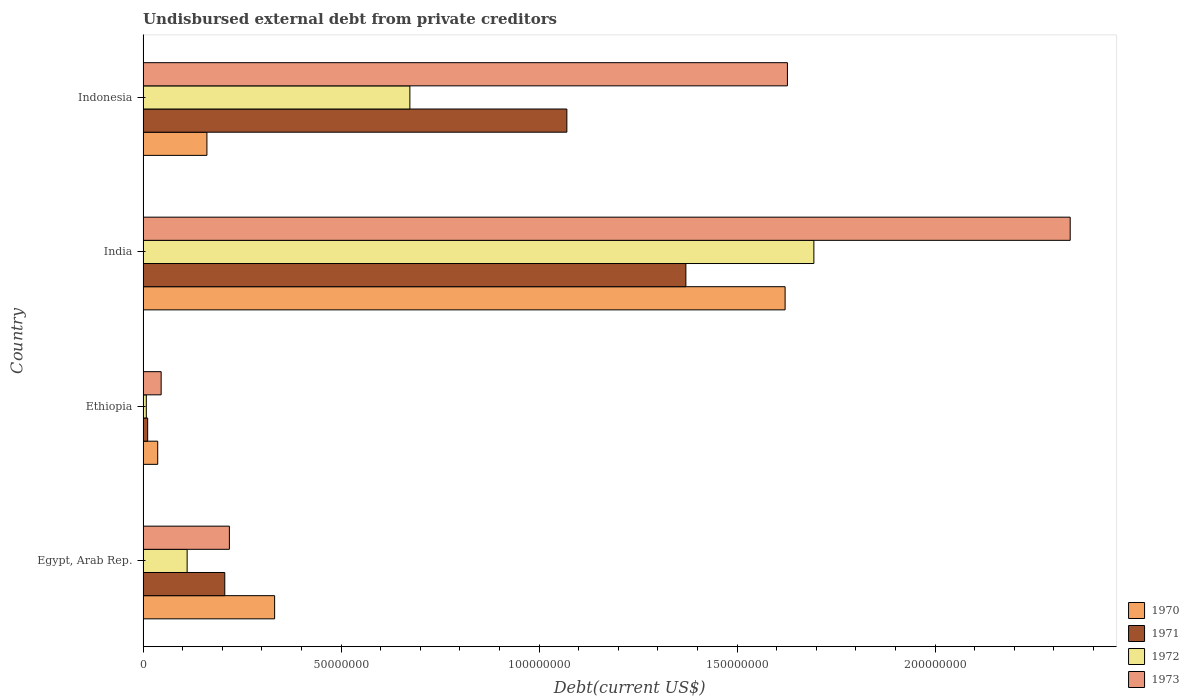How many groups of bars are there?
Keep it short and to the point. 4. Are the number of bars per tick equal to the number of legend labels?
Offer a very short reply. Yes. How many bars are there on the 1st tick from the bottom?
Your answer should be compact. 4. What is the label of the 2nd group of bars from the top?
Your response must be concise. India. What is the total debt in 1971 in Egypt, Arab Rep.?
Provide a short and direct response. 2.06e+07. Across all countries, what is the maximum total debt in 1970?
Give a very brief answer. 1.62e+08. Across all countries, what is the minimum total debt in 1973?
Your response must be concise. 4.57e+06. In which country was the total debt in 1972 minimum?
Make the answer very short. Ethiopia. What is the total total debt in 1973 in the graph?
Provide a short and direct response. 4.23e+08. What is the difference between the total debt in 1970 in Ethiopia and that in India?
Your response must be concise. -1.58e+08. What is the difference between the total debt in 1972 in Indonesia and the total debt in 1973 in Ethiopia?
Your answer should be very brief. 6.28e+07. What is the average total debt in 1971 per country?
Offer a very short reply. 6.65e+07. What is the difference between the total debt in 1971 and total debt in 1972 in Indonesia?
Offer a very short reply. 3.96e+07. What is the ratio of the total debt in 1972 in Ethiopia to that in India?
Ensure brevity in your answer.  0. Is the total debt in 1970 in Ethiopia less than that in Indonesia?
Offer a terse response. Yes. Is the difference between the total debt in 1971 in Ethiopia and India greater than the difference between the total debt in 1972 in Ethiopia and India?
Keep it short and to the point. Yes. What is the difference between the highest and the second highest total debt in 1970?
Provide a short and direct response. 1.29e+08. What is the difference between the highest and the lowest total debt in 1973?
Your answer should be very brief. 2.30e+08. Is the sum of the total debt in 1973 in Egypt, Arab Rep. and India greater than the maximum total debt in 1970 across all countries?
Make the answer very short. Yes. Is it the case that in every country, the sum of the total debt in 1970 and total debt in 1971 is greater than the sum of total debt in 1973 and total debt in 1972?
Offer a terse response. No. What does the 4th bar from the top in Indonesia represents?
Provide a short and direct response. 1970. Are all the bars in the graph horizontal?
Keep it short and to the point. Yes. How many countries are there in the graph?
Ensure brevity in your answer.  4. Where does the legend appear in the graph?
Your answer should be very brief. Bottom right. How many legend labels are there?
Offer a very short reply. 4. What is the title of the graph?
Your answer should be very brief. Undisbursed external debt from private creditors. What is the label or title of the X-axis?
Ensure brevity in your answer.  Debt(current US$). What is the label or title of the Y-axis?
Your response must be concise. Country. What is the Debt(current US$) in 1970 in Egypt, Arab Rep.?
Provide a succinct answer. 3.32e+07. What is the Debt(current US$) of 1971 in Egypt, Arab Rep.?
Give a very brief answer. 2.06e+07. What is the Debt(current US$) in 1972 in Egypt, Arab Rep.?
Give a very brief answer. 1.11e+07. What is the Debt(current US$) in 1973 in Egypt, Arab Rep.?
Provide a succinct answer. 2.18e+07. What is the Debt(current US$) of 1970 in Ethiopia?
Provide a short and direct response. 3.70e+06. What is the Debt(current US$) in 1971 in Ethiopia?
Make the answer very short. 1.16e+06. What is the Debt(current US$) in 1972 in Ethiopia?
Offer a terse response. 8.20e+05. What is the Debt(current US$) of 1973 in Ethiopia?
Offer a very short reply. 4.57e+06. What is the Debt(current US$) in 1970 in India?
Make the answer very short. 1.62e+08. What is the Debt(current US$) of 1971 in India?
Keep it short and to the point. 1.37e+08. What is the Debt(current US$) in 1972 in India?
Your answer should be compact. 1.69e+08. What is the Debt(current US$) of 1973 in India?
Provide a short and direct response. 2.34e+08. What is the Debt(current US$) in 1970 in Indonesia?
Provide a short and direct response. 1.61e+07. What is the Debt(current US$) of 1971 in Indonesia?
Give a very brief answer. 1.07e+08. What is the Debt(current US$) of 1972 in Indonesia?
Offer a terse response. 6.74e+07. What is the Debt(current US$) in 1973 in Indonesia?
Provide a short and direct response. 1.63e+08. Across all countries, what is the maximum Debt(current US$) of 1970?
Your answer should be very brief. 1.62e+08. Across all countries, what is the maximum Debt(current US$) in 1971?
Make the answer very short. 1.37e+08. Across all countries, what is the maximum Debt(current US$) of 1972?
Your answer should be very brief. 1.69e+08. Across all countries, what is the maximum Debt(current US$) in 1973?
Offer a very short reply. 2.34e+08. Across all countries, what is the minimum Debt(current US$) of 1970?
Make the answer very short. 3.70e+06. Across all countries, what is the minimum Debt(current US$) in 1971?
Keep it short and to the point. 1.16e+06. Across all countries, what is the minimum Debt(current US$) of 1972?
Provide a short and direct response. 8.20e+05. Across all countries, what is the minimum Debt(current US$) of 1973?
Keep it short and to the point. 4.57e+06. What is the total Debt(current US$) in 1970 in the graph?
Your answer should be compact. 2.15e+08. What is the total Debt(current US$) in 1971 in the graph?
Give a very brief answer. 2.66e+08. What is the total Debt(current US$) of 1972 in the graph?
Your response must be concise. 2.49e+08. What is the total Debt(current US$) of 1973 in the graph?
Provide a succinct answer. 4.23e+08. What is the difference between the Debt(current US$) in 1970 in Egypt, Arab Rep. and that in Ethiopia?
Keep it short and to the point. 2.95e+07. What is the difference between the Debt(current US$) of 1971 in Egypt, Arab Rep. and that in Ethiopia?
Make the answer very short. 1.95e+07. What is the difference between the Debt(current US$) in 1972 in Egypt, Arab Rep. and that in Ethiopia?
Your response must be concise. 1.03e+07. What is the difference between the Debt(current US$) in 1973 in Egypt, Arab Rep. and that in Ethiopia?
Provide a short and direct response. 1.72e+07. What is the difference between the Debt(current US$) in 1970 in Egypt, Arab Rep. and that in India?
Provide a succinct answer. -1.29e+08. What is the difference between the Debt(current US$) of 1971 in Egypt, Arab Rep. and that in India?
Your answer should be very brief. -1.16e+08. What is the difference between the Debt(current US$) of 1972 in Egypt, Arab Rep. and that in India?
Provide a succinct answer. -1.58e+08. What is the difference between the Debt(current US$) of 1973 in Egypt, Arab Rep. and that in India?
Offer a very short reply. -2.12e+08. What is the difference between the Debt(current US$) of 1970 in Egypt, Arab Rep. and that in Indonesia?
Provide a succinct answer. 1.71e+07. What is the difference between the Debt(current US$) in 1971 in Egypt, Arab Rep. and that in Indonesia?
Provide a succinct answer. -8.64e+07. What is the difference between the Debt(current US$) of 1972 in Egypt, Arab Rep. and that in Indonesia?
Your response must be concise. -5.62e+07. What is the difference between the Debt(current US$) of 1973 in Egypt, Arab Rep. and that in Indonesia?
Provide a succinct answer. -1.41e+08. What is the difference between the Debt(current US$) of 1970 in Ethiopia and that in India?
Provide a succinct answer. -1.58e+08. What is the difference between the Debt(current US$) in 1971 in Ethiopia and that in India?
Your answer should be compact. -1.36e+08. What is the difference between the Debt(current US$) in 1972 in Ethiopia and that in India?
Offer a terse response. -1.69e+08. What is the difference between the Debt(current US$) in 1973 in Ethiopia and that in India?
Offer a very short reply. -2.30e+08. What is the difference between the Debt(current US$) in 1970 in Ethiopia and that in Indonesia?
Keep it short and to the point. -1.24e+07. What is the difference between the Debt(current US$) of 1971 in Ethiopia and that in Indonesia?
Provide a short and direct response. -1.06e+08. What is the difference between the Debt(current US$) in 1972 in Ethiopia and that in Indonesia?
Keep it short and to the point. -6.66e+07. What is the difference between the Debt(current US$) in 1973 in Ethiopia and that in Indonesia?
Make the answer very short. -1.58e+08. What is the difference between the Debt(current US$) in 1970 in India and that in Indonesia?
Ensure brevity in your answer.  1.46e+08. What is the difference between the Debt(current US$) in 1971 in India and that in Indonesia?
Give a very brief answer. 3.00e+07. What is the difference between the Debt(current US$) in 1972 in India and that in Indonesia?
Offer a terse response. 1.02e+08. What is the difference between the Debt(current US$) in 1973 in India and that in Indonesia?
Your answer should be very brief. 7.14e+07. What is the difference between the Debt(current US$) of 1970 in Egypt, Arab Rep. and the Debt(current US$) of 1971 in Ethiopia?
Keep it short and to the point. 3.21e+07. What is the difference between the Debt(current US$) in 1970 in Egypt, Arab Rep. and the Debt(current US$) in 1972 in Ethiopia?
Provide a short and direct response. 3.24e+07. What is the difference between the Debt(current US$) in 1970 in Egypt, Arab Rep. and the Debt(current US$) in 1973 in Ethiopia?
Your response must be concise. 2.87e+07. What is the difference between the Debt(current US$) in 1971 in Egypt, Arab Rep. and the Debt(current US$) in 1972 in Ethiopia?
Give a very brief answer. 1.98e+07. What is the difference between the Debt(current US$) of 1971 in Egypt, Arab Rep. and the Debt(current US$) of 1973 in Ethiopia?
Your response must be concise. 1.61e+07. What is the difference between the Debt(current US$) of 1972 in Egypt, Arab Rep. and the Debt(current US$) of 1973 in Ethiopia?
Your answer should be very brief. 6.56e+06. What is the difference between the Debt(current US$) of 1970 in Egypt, Arab Rep. and the Debt(current US$) of 1971 in India?
Offer a terse response. -1.04e+08. What is the difference between the Debt(current US$) in 1970 in Egypt, Arab Rep. and the Debt(current US$) in 1972 in India?
Provide a short and direct response. -1.36e+08. What is the difference between the Debt(current US$) in 1970 in Egypt, Arab Rep. and the Debt(current US$) in 1973 in India?
Your answer should be very brief. -2.01e+08. What is the difference between the Debt(current US$) in 1971 in Egypt, Arab Rep. and the Debt(current US$) in 1972 in India?
Provide a short and direct response. -1.49e+08. What is the difference between the Debt(current US$) in 1971 in Egypt, Arab Rep. and the Debt(current US$) in 1973 in India?
Offer a very short reply. -2.13e+08. What is the difference between the Debt(current US$) of 1972 in Egypt, Arab Rep. and the Debt(current US$) of 1973 in India?
Offer a very short reply. -2.23e+08. What is the difference between the Debt(current US$) of 1970 in Egypt, Arab Rep. and the Debt(current US$) of 1971 in Indonesia?
Your response must be concise. -7.38e+07. What is the difference between the Debt(current US$) in 1970 in Egypt, Arab Rep. and the Debt(current US$) in 1972 in Indonesia?
Offer a very short reply. -3.42e+07. What is the difference between the Debt(current US$) of 1970 in Egypt, Arab Rep. and the Debt(current US$) of 1973 in Indonesia?
Your answer should be compact. -1.29e+08. What is the difference between the Debt(current US$) of 1971 in Egypt, Arab Rep. and the Debt(current US$) of 1972 in Indonesia?
Give a very brief answer. -4.67e+07. What is the difference between the Debt(current US$) of 1971 in Egypt, Arab Rep. and the Debt(current US$) of 1973 in Indonesia?
Provide a succinct answer. -1.42e+08. What is the difference between the Debt(current US$) of 1972 in Egypt, Arab Rep. and the Debt(current US$) of 1973 in Indonesia?
Offer a very short reply. -1.52e+08. What is the difference between the Debt(current US$) in 1970 in Ethiopia and the Debt(current US$) in 1971 in India?
Offer a terse response. -1.33e+08. What is the difference between the Debt(current US$) in 1970 in Ethiopia and the Debt(current US$) in 1972 in India?
Your answer should be compact. -1.66e+08. What is the difference between the Debt(current US$) in 1970 in Ethiopia and the Debt(current US$) in 1973 in India?
Provide a short and direct response. -2.30e+08. What is the difference between the Debt(current US$) in 1971 in Ethiopia and the Debt(current US$) in 1972 in India?
Your response must be concise. -1.68e+08. What is the difference between the Debt(current US$) in 1971 in Ethiopia and the Debt(current US$) in 1973 in India?
Keep it short and to the point. -2.33e+08. What is the difference between the Debt(current US$) in 1972 in Ethiopia and the Debt(current US$) in 1973 in India?
Ensure brevity in your answer.  -2.33e+08. What is the difference between the Debt(current US$) of 1970 in Ethiopia and the Debt(current US$) of 1971 in Indonesia?
Provide a short and direct response. -1.03e+08. What is the difference between the Debt(current US$) in 1970 in Ethiopia and the Debt(current US$) in 1972 in Indonesia?
Provide a short and direct response. -6.37e+07. What is the difference between the Debt(current US$) in 1970 in Ethiopia and the Debt(current US$) in 1973 in Indonesia?
Offer a very short reply. -1.59e+08. What is the difference between the Debt(current US$) of 1971 in Ethiopia and the Debt(current US$) of 1972 in Indonesia?
Ensure brevity in your answer.  -6.62e+07. What is the difference between the Debt(current US$) in 1971 in Ethiopia and the Debt(current US$) in 1973 in Indonesia?
Provide a short and direct response. -1.62e+08. What is the difference between the Debt(current US$) of 1972 in Ethiopia and the Debt(current US$) of 1973 in Indonesia?
Offer a terse response. -1.62e+08. What is the difference between the Debt(current US$) of 1970 in India and the Debt(current US$) of 1971 in Indonesia?
Ensure brevity in your answer.  5.51e+07. What is the difference between the Debt(current US$) in 1970 in India and the Debt(current US$) in 1972 in Indonesia?
Make the answer very short. 9.47e+07. What is the difference between the Debt(current US$) of 1970 in India and the Debt(current US$) of 1973 in Indonesia?
Offer a very short reply. -5.84e+05. What is the difference between the Debt(current US$) of 1971 in India and the Debt(current US$) of 1972 in Indonesia?
Make the answer very short. 6.97e+07. What is the difference between the Debt(current US$) of 1971 in India and the Debt(current US$) of 1973 in Indonesia?
Offer a terse response. -2.56e+07. What is the difference between the Debt(current US$) of 1972 in India and the Debt(current US$) of 1973 in Indonesia?
Provide a short and direct response. 6.68e+06. What is the average Debt(current US$) in 1970 per country?
Provide a succinct answer. 5.38e+07. What is the average Debt(current US$) in 1971 per country?
Ensure brevity in your answer.  6.65e+07. What is the average Debt(current US$) in 1972 per country?
Your response must be concise. 6.22e+07. What is the average Debt(current US$) in 1973 per country?
Provide a succinct answer. 1.06e+08. What is the difference between the Debt(current US$) in 1970 and Debt(current US$) in 1971 in Egypt, Arab Rep.?
Provide a short and direct response. 1.26e+07. What is the difference between the Debt(current US$) in 1970 and Debt(current US$) in 1972 in Egypt, Arab Rep.?
Offer a terse response. 2.21e+07. What is the difference between the Debt(current US$) of 1970 and Debt(current US$) of 1973 in Egypt, Arab Rep.?
Your answer should be compact. 1.14e+07. What is the difference between the Debt(current US$) of 1971 and Debt(current US$) of 1972 in Egypt, Arab Rep.?
Your answer should be compact. 9.50e+06. What is the difference between the Debt(current US$) of 1971 and Debt(current US$) of 1973 in Egypt, Arab Rep.?
Provide a short and direct response. -1.17e+06. What is the difference between the Debt(current US$) of 1972 and Debt(current US$) of 1973 in Egypt, Arab Rep.?
Offer a terse response. -1.07e+07. What is the difference between the Debt(current US$) of 1970 and Debt(current US$) of 1971 in Ethiopia?
Offer a terse response. 2.53e+06. What is the difference between the Debt(current US$) in 1970 and Debt(current US$) in 1972 in Ethiopia?
Provide a short and direct response. 2.88e+06. What is the difference between the Debt(current US$) of 1970 and Debt(current US$) of 1973 in Ethiopia?
Give a very brief answer. -8.70e+05. What is the difference between the Debt(current US$) in 1971 and Debt(current US$) in 1972 in Ethiopia?
Your response must be concise. 3.45e+05. What is the difference between the Debt(current US$) of 1971 and Debt(current US$) of 1973 in Ethiopia?
Offer a very short reply. -3.40e+06. What is the difference between the Debt(current US$) in 1972 and Debt(current US$) in 1973 in Ethiopia?
Your answer should be very brief. -3.75e+06. What is the difference between the Debt(current US$) in 1970 and Debt(current US$) in 1971 in India?
Provide a short and direct response. 2.51e+07. What is the difference between the Debt(current US$) in 1970 and Debt(current US$) in 1972 in India?
Offer a very short reply. -7.26e+06. What is the difference between the Debt(current US$) in 1970 and Debt(current US$) in 1973 in India?
Keep it short and to the point. -7.20e+07. What is the difference between the Debt(current US$) in 1971 and Debt(current US$) in 1972 in India?
Offer a very short reply. -3.23e+07. What is the difference between the Debt(current US$) in 1971 and Debt(current US$) in 1973 in India?
Give a very brief answer. -9.70e+07. What is the difference between the Debt(current US$) in 1972 and Debt(current US$) in 1973 in India?
Keep it short and to the point. -6.47e+07. What is the difference between the Debt(current US$) of 1970 and Debt(current US$) of 1971 in Indonesia?
Your answer should be compact. -9.09e+07. What is the difference between the Debt(current US$) of 1970 and Debt(current US$) of 1972 in Indonesia?
Your answer should be compact. -5.12e+07. What is the difference between the Debt(current US$) in 1970 and Debt(current US$) in 1973 in Indonesia?
Give a very brief answer. -1.47e+08. What is the difference between the Debt(current US$) of 1971 and Debt(current US$) of 1972 in Indonesia?
Your answer should be compact. 3.96e+07. What is the difference between the Debt(current US$) in 1971 and Debt(current US$) in 1973 in Indonesia?
Your response must be concise. -5.57e+07. What is the difference between the Debt(current US$) of 1972 and Debt(current US$) of 1973 in Indonesia?
Offer a terse response. -9.53e+07. What is the ratio of the Debt(current US$) of 1970 in Egypt, Arab Rep. to that in Ethiopia?
Your answer should be compact. 8.99. What is the ratio of the Debt(current US$) of 1971 in Egypt, Arab Rep. to that in Ethiopia?
Keep it short and to the point. 17.71. What is the ratio of the Debt(current US$) of 1972 in Egypt, Arab Rep. to that in Ethiopia?
Ensure brevity in your answer.  13.57. What is the ratio of the Debt(current US$) in 1973 in Egypt, Arab Rep. to that in Ethiopia?
Your answer should be very brief. 4.77. What is the ratio of the Debt(current US$) of 1970 in Egypt, Arab Rep. to that in India?
Provide a short and direct response. 0.2. What is the ratio of the Debt(current US$) of 1971 in Egypt, Arab Rep. to that in India?
Make the answer very short. 0.15. What is the ratio of the Debt(current US$) in 1972 in Egypt, Arab Rep. to that in India?
Give a very brief answer. 0.07. What is the ratio of the Debt(current US$) of 1973 in Egypt, Arab Rep. to that in India?
Ensure brevity in your answer.  0.09. What is the ratio of the Debt(current US$) of 1970 in Egypt, Arab Rep. to that in Indonesia?
Ensure brevity in your answer.  2.06. What is the ratio of the Debt(current US$) of 1971 in Egypt, Arab Rep. to that in Indonesia?
Your response must be concise. 0.19. What is the ratio of the Debt(current US$) in 1972 in Egypt, Arab Rep. to that in Indonesia?
Provide a succinct answer. 0.17. What is the ratio of the Debt(current US$) of 1973 in Egypt, Arab Rep. to that in Indonesia?
Provide a short and direct response. 0.13. What is the ratio of the Debt(current US$) in 1970 in Ethiopia to that in India?
Offer a very short reply. 0.02. What is the ratio of the Debt(current US$) in 1971 in Ethiopia to that in India?
Make the answer very short. 0.01. What is the ratio of the Debt(current US$) in 1972 in Ethiopia to that in India?
Give a very brief answer. 0. What is the ratio of the Debt(current US$) in 1973 in Ethiopia to that in India?
Make the answer very short. 0.02. What is the ratio of the Debt(current US$) of 1970 in Ethiopia to that in Indonesia?
Offer a very short reply. 0.23. What is the ratio of the Debt(current US$) of 1971 in Ethiopia to that in Indonesia?
Ensure brevity in your answer.  0.01. What is the ratio of the Debt(current US$) in 1972 in Ethiopia to that in Indonesia?
Your answer should be very brief. 0.01. What is the ratio of the Debt(current US$) in 1973 in Ethiopia to that in Indonesia?
Give a very brief answer. 0.03. What is the ratio of the Debt(current US$) of 1970 in India to that in Indonesia?
Ensure brevity in your answer.  10.05. What is the ratio of the Debt(current US$) of 1971 in India to that in Indonesia?
Your answer should be very brief. 1.28. What is the ratio of the Debt(current US$) of 1972 in India to that in Indonesia?
Provide a short and direct response. 2.51. What is the ratio of the Debt(current US$) of 1973 in India to that in Indonesia?
Keep it short and to the point. 1.44. What is the difference between the highest and the second highest Debt(current US$) in 1970?
Your answer should be compact. 1.29e+08. What is the difference between the highest and the second highest Debt(current US$) of 1971?
Make the answer very short. 3.00e+07. What is the difference between the highest and the second highest Debt(current US$) in 1972?
Offer a terse response. 1.02e+08. What is the difference between the highest and the second highest Debt(current US$) in 1973?
Give a very brief answer. 7.14e+07. What is the difference between the highest and the lowest Debt(current US$) of 1970?
Provide a short and direct response. 1.58e+08. What is the difference between the highest and the lowest Debt(current US$) in 1971?
Offer a terse response. 1.36e+08. What is the difference between the highest and the lowest Debt(current US$) in 1972?
Provide a short and direct response. 1.69e+08. What is the difference between the highest and the lowest Debt(current US$) in 1973?
Your answer should be very brief. 2.30e+08. 